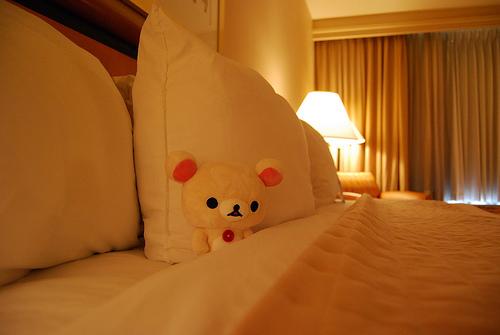Is it night or day outside the window?
Keep it brief. Day. Is the light on?
Short answer required. Yes. Is this bed made?
Answer briefly. Yes. What is on the bed?
Quick response, please. Teddy bear. 